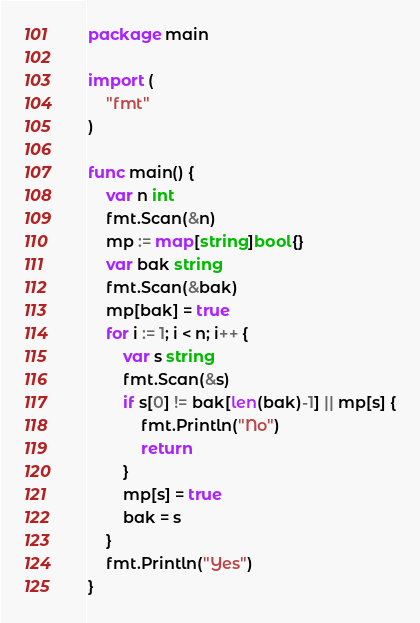<code> <loc_0><loc_0><loc_500><loc_500><_Go_>package main

import (
	"fmt"
)

func main() {
	var n int
	fmt.Scan(&n)
	mp := map[string]bool{}
	var bak string
	fmt.Scan(&bak)
	mp[bak] = true
	for i := 1; i < n; i++ {
		var s string
		fmt.Scan(&s)
		if s[0] != bak[len(bak)-1] || mp[s] {
			fmt.Println("No")
			return
		}
		mp[s] = true
		bak = s
	}
	fmt.Println("Yes")
}
</code> 